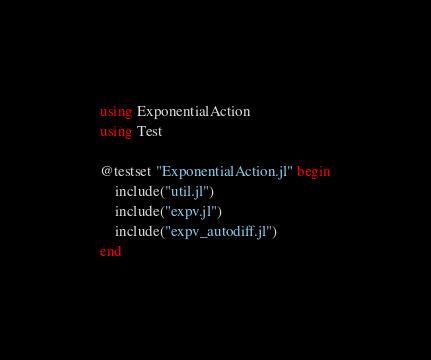Convert code to text. <code><loc_0><loc_0><loc_500><loc_500><_Julia_>using ExponentialAction
using Test

@testset "ExponentialAction.jl" begin
    include("util.jl")
    include("expv.jl")
    include("expv_autodiff.jl")
end
</code> 